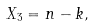<formula> <loc_0><loc_0><loc_500><loc_500>X _ { 3 } = n - { k } ,</formula> 